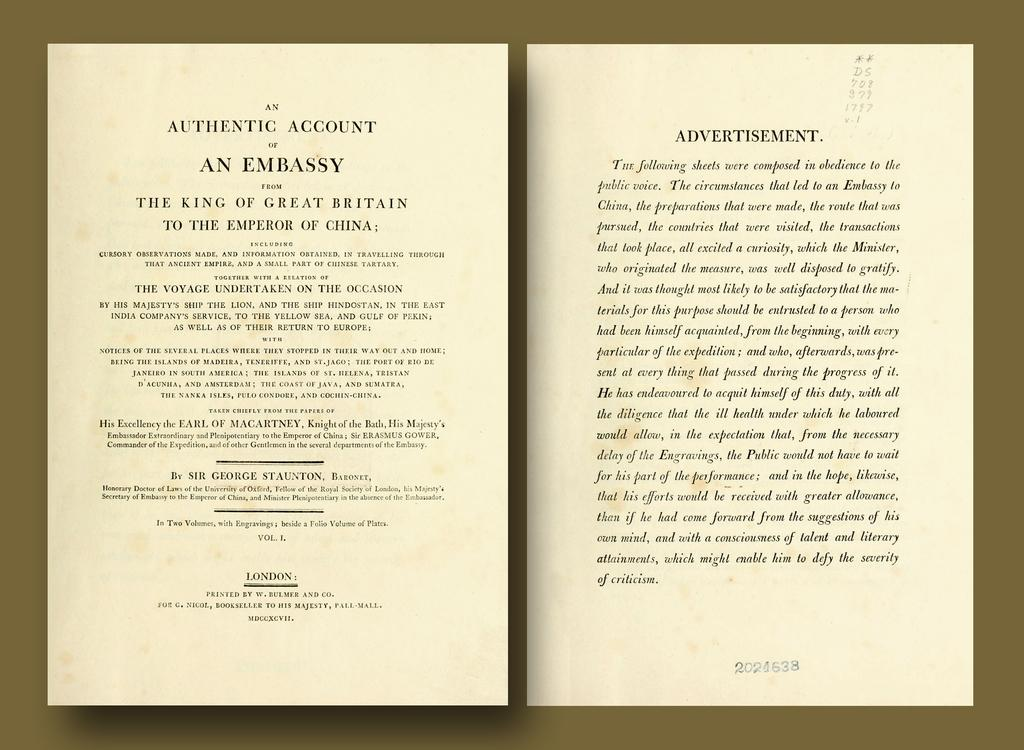<image>
Share a concise interpretation of the image provided. an open book to the page that says an authentic account 